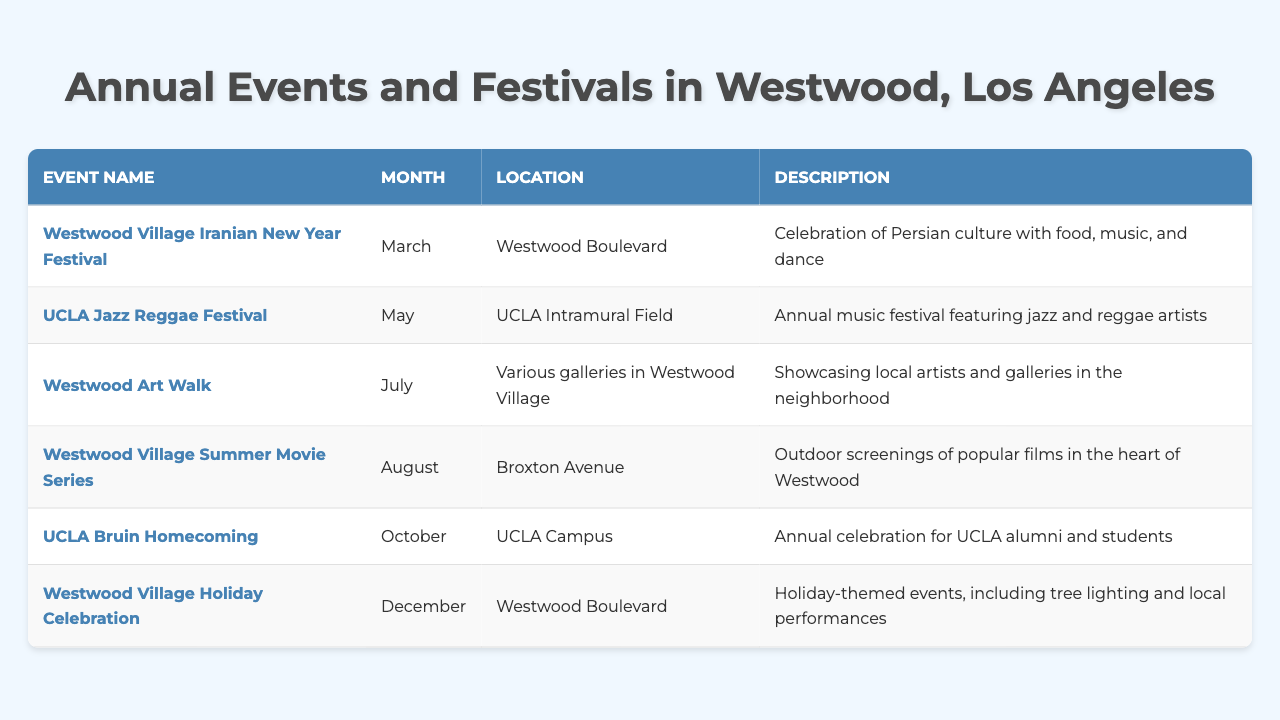What is the name of the festival celebrating Persian culture? The table lists the "Westwood Village Iranian New Year Festival" as the event celebrating Persian culture.
Answer: Westwood Village Iranian New Year Festival In which month does the UCLA Bruin Homecoming take place? According to the table, the UCLA Bruin Homecoming is scheduled for October.
Answer: October Where is the Westwood Art Walk held? The table indicates that the Westwood Art Walk takes place at various galleries in Westwood Village.
Answer: Various galleries in Westwood Village How many events take place in August? The table shows that there is one event scheduled in August, which is the Westwood Village Summer Movie Series.
Answer: 1 Is there an event happening in December? Yes, the table confirms there is an event in December called the Westwood Village Holiday Celebration.
Answer: Yes Which event is held on Broxton Avenue? The Westwood Village Summer Movie Series is the event that takes place on Broxton Avenue as per the table.
Answer: Westwood Village Summer Movie Series What type of music is featured in the UCLA Jazz Reggae Festival? The table specifies that the UCLA Jazz Reggae Festival features jazz and reggae artists.
Answer: Jazz and reggae How many months are represented in the annual events listed? There are six distinct months represented for the events in the table: March, May, July, August, October, and December, indicating a total of six months.
Answer: 6 Which event occurs right before the Westwood Village Holiday Celebration? The UCLA Bruin Homecoming occurs right before the Westwood Village Holiday Celebration in October, as shown in the table.
Answer: UCLA Bruin Homecoming If I wanted to see local artists, which festival should I attend? You should attend the Westwood Art Walk, as it showcases local artists and galleries in the neighborhood.
Answer: Westwood Art Walk During which month is the Westwood Village Holiday Celebration? This event takes place in December, according to the information in the table.
Answer: December 